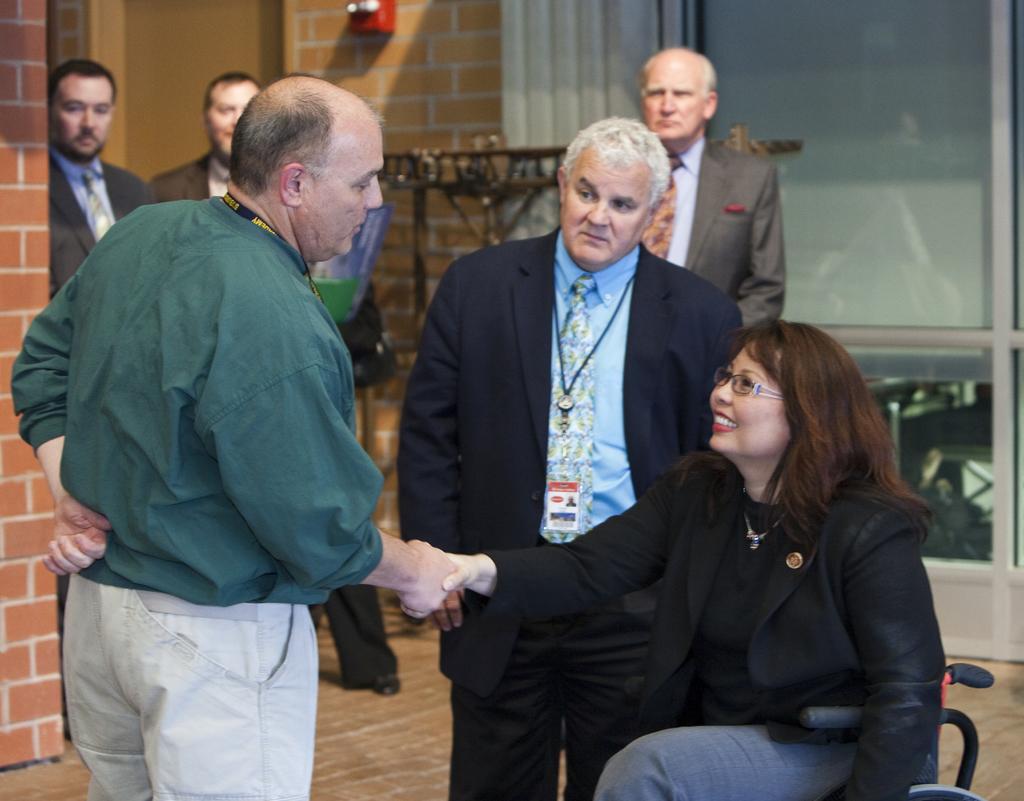Please provide a concise description of this image. In this picture I can see few people standing and a woman seated on the wheel chair and I can see a man and woman shaking their hands, it looks like a inner view of a building. 